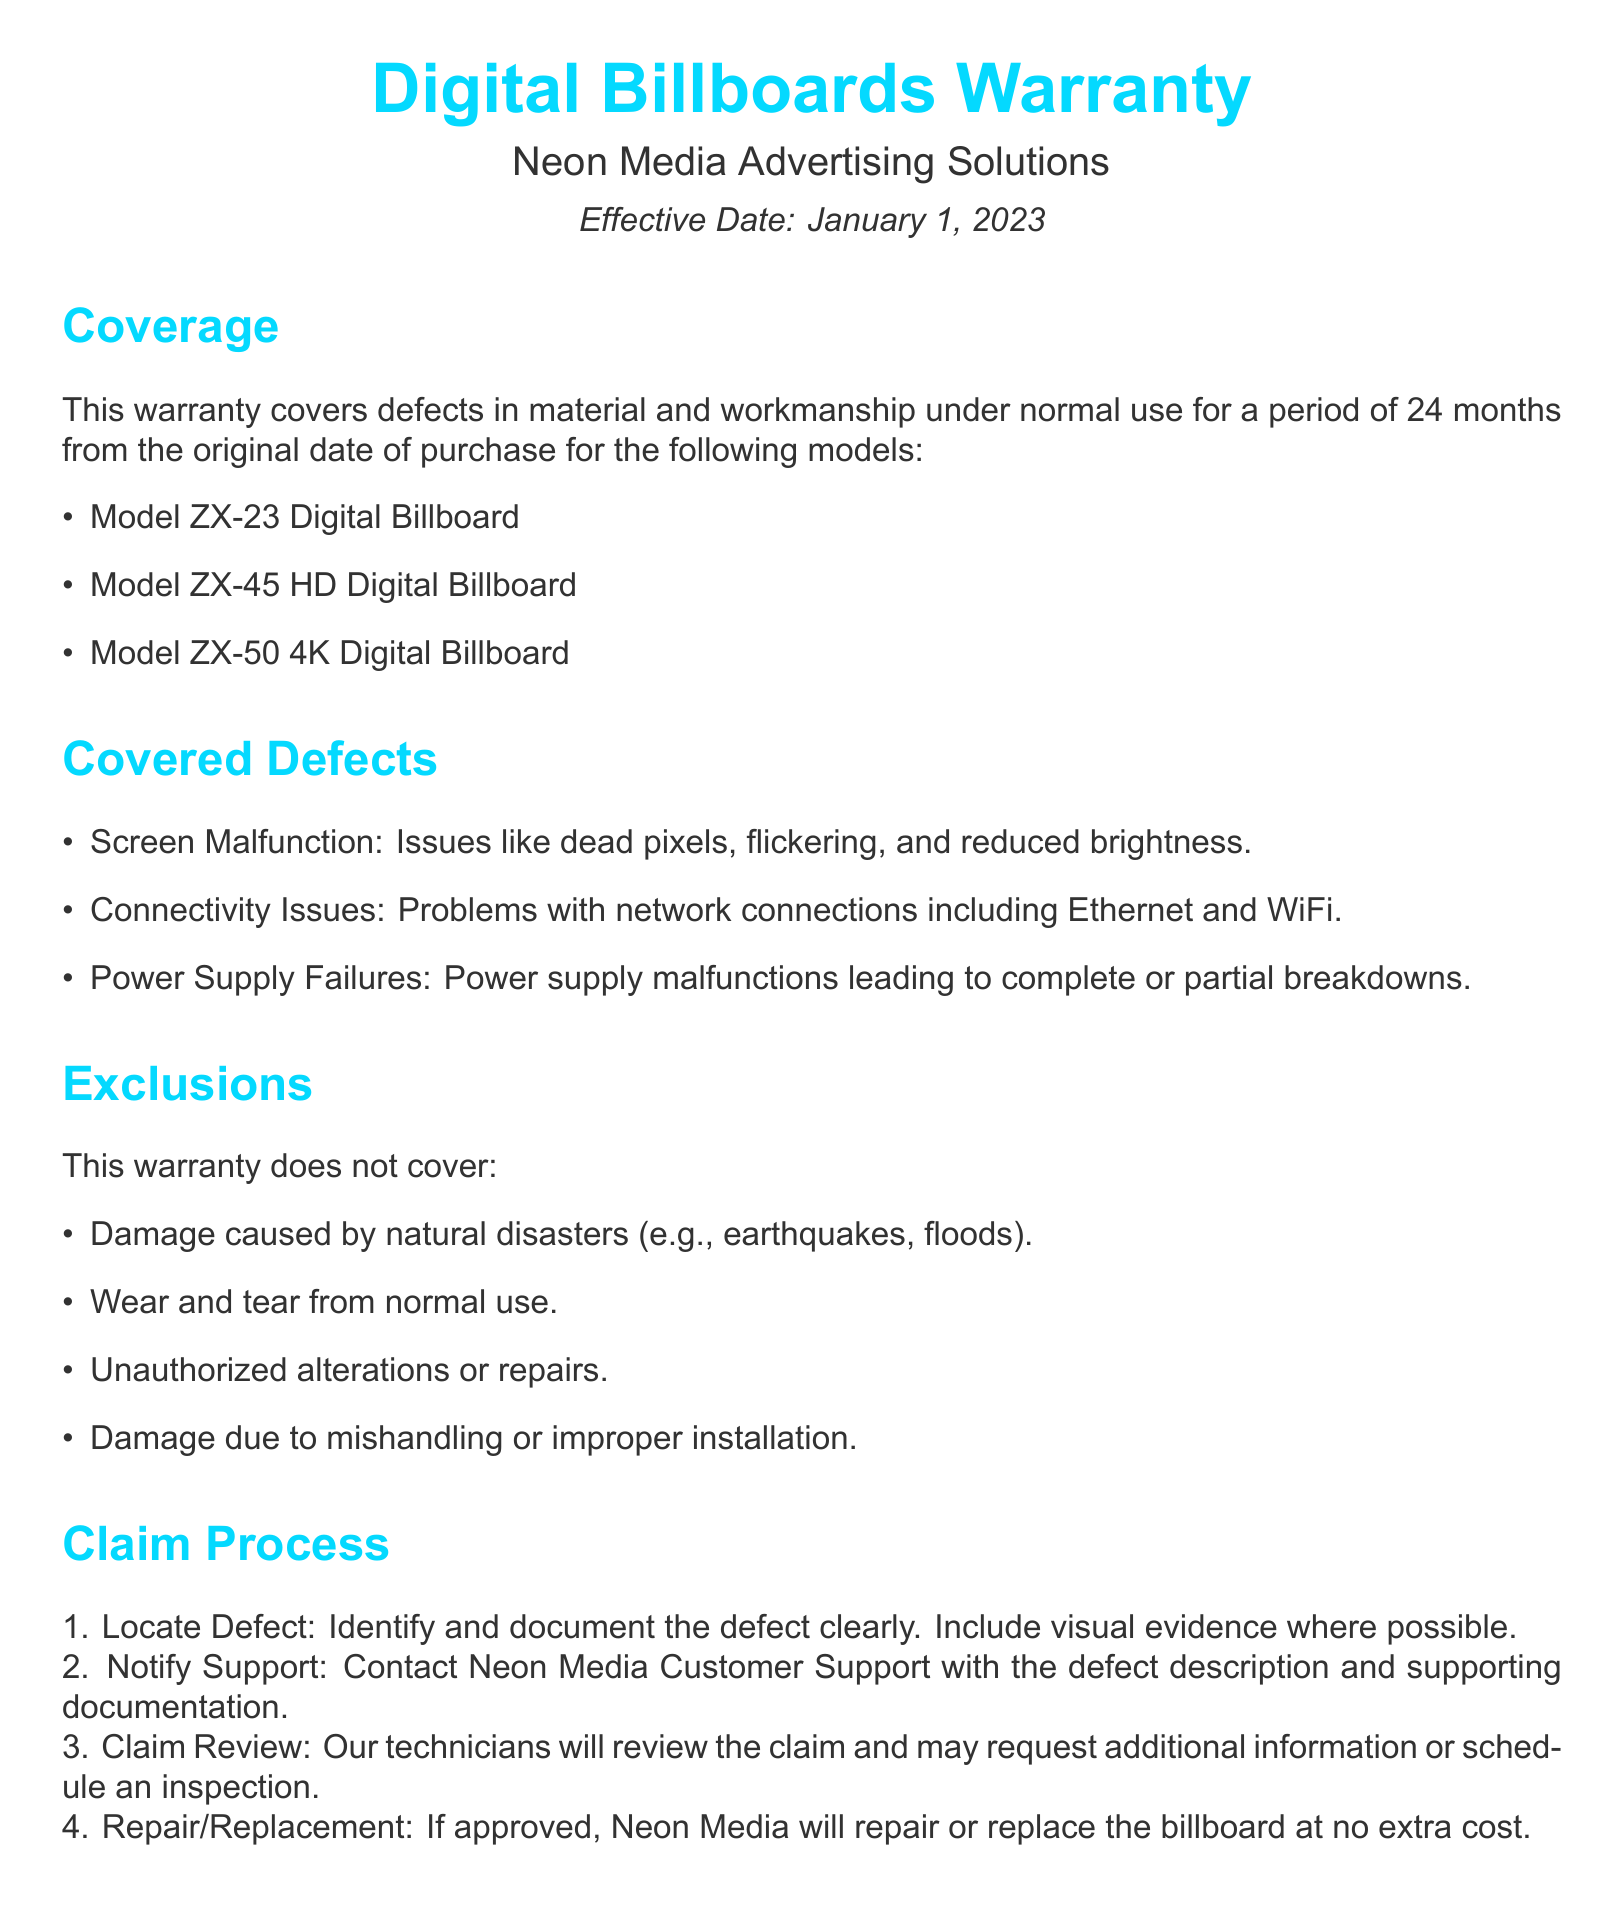What is the warranty period for the digital billboards? The warranty is valid for a period of 24 months from the original date of purchase.
Answer: 24 months What models are covered under this warranty? The document lists specific models under coverage, which include Model ZX-23, Model ZX-45 HD, and Model ZX-50 4K Digital Billboard.
Answer: Model ZX-23, Model ZX-45 HD, Model ZX-50 4K What is excluded from the warranty coverage? The document lists exclusions, including damage caused by natural disasters.
Answer: Damage caused by natural disasters What must be included when documenting a defect? The claim process specifies that visual evidence should be included when documenting a defect.
Answer: Visual evidence Who should be contacted for warranty claims? Contact information provided in the document indicates which support service to reach out to.
Answer: Neon Media Customer Support What is one responsibility of the customer? The document outlines the customer's responsibilities, including the need to perform regular maintenance checks.
Answer: Perform regular maintenance checks What type of issues does this warranty cover? The covered defects section details the types of issues, such as screen malfunctions.
Answer: Screen Malfunction When was the warranty effective? The effective date is noted in the document and specifies when the warranty starts.
Answer: January 1, 2023 